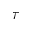Convert formula to latex. <formula><loc_0><loc_0><loc_500><loc_500>\tau</formula> 